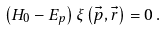<formula> <loc_0><loc_0><loc_500><loc_500>\left ( H _ { 0 } - E _ { p } \right ) \xi \left ( \vec { p } , \vec { r } \right ) = 0 \, .</formula> 